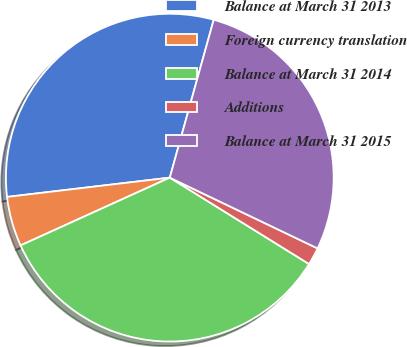Convert chart. <chart><loc_0><loc_0><loc_500><loc_500><pie_chart><fcel>Balance at March 31 2013<fcel>Foreign currency translation<fcel>Balance at March 31 2014<fcel>Additions<fcel>Balance at March 31 2015<nl><fcel>31.2%<fcel>4.91%<fcel>34.38%<fcel>1.73%<fcel>27.79%<nl></chart> 